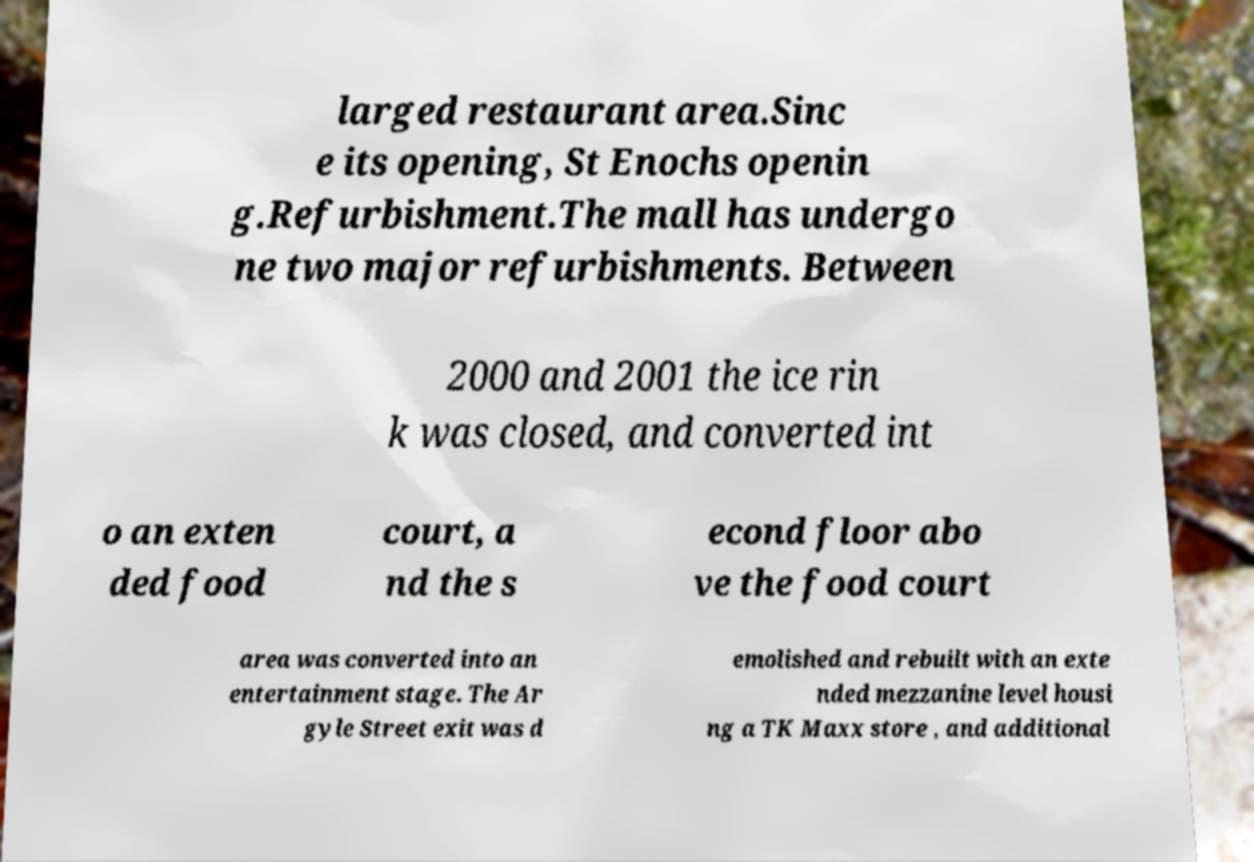Could you extract and type out the text from this image? larged restaurant area.Sinc e its opening, St Enochs openin g.Refurbishment.The mall has undergo ne two major refurbishments. Between 2000 and 2001 the ice rin k was closed, and converted int o an exten ded food court, a nd the s econd floor abo ve the food court area was converted into an entertainment stage. The Ar gyle Street exit was d emolished and rebuilt with an exte nded mezzanine level housi ng a TK Maxx store , and additional 